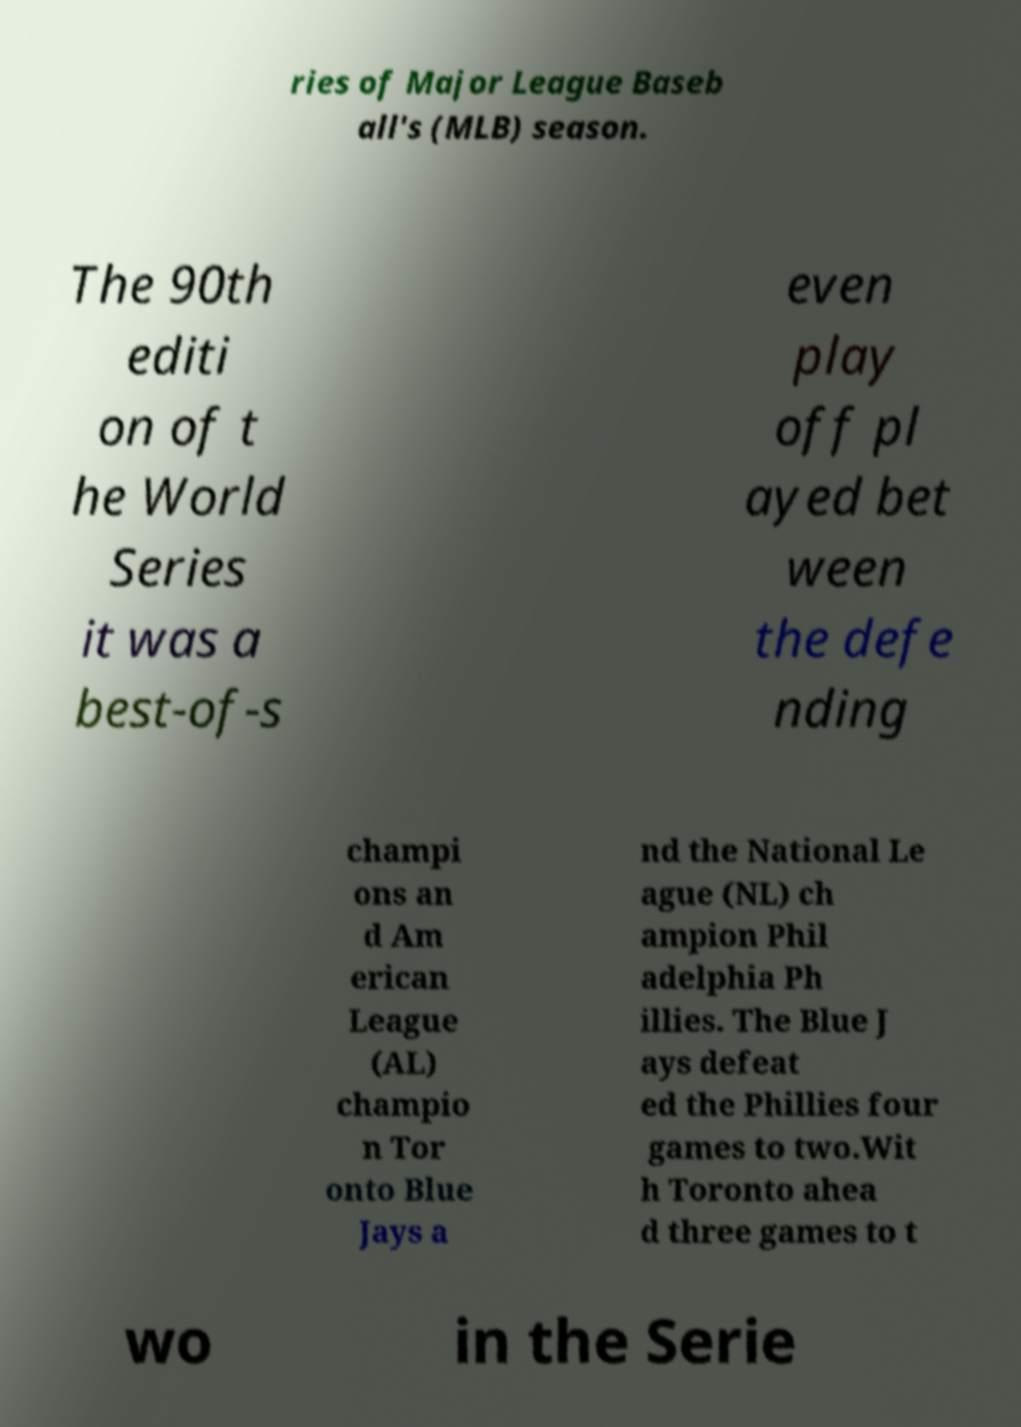Please read and relay the text visible in this image. What does it say? ries of Major League Baseb all's (MLB) season. The 90th editi on of t he World Series it was a best-of-s even play off pl ayed bet ween the defe nding champi ons an d Am erican League (AL) champio n Tor onto Blue Jays a nd the National Le ague (NL) ch ampion Phil adelphia Ph illies. The Blue J ays defeat ed the Phillies four games to two.Wit h Toronto ahea d three games to t wo in the Serie 